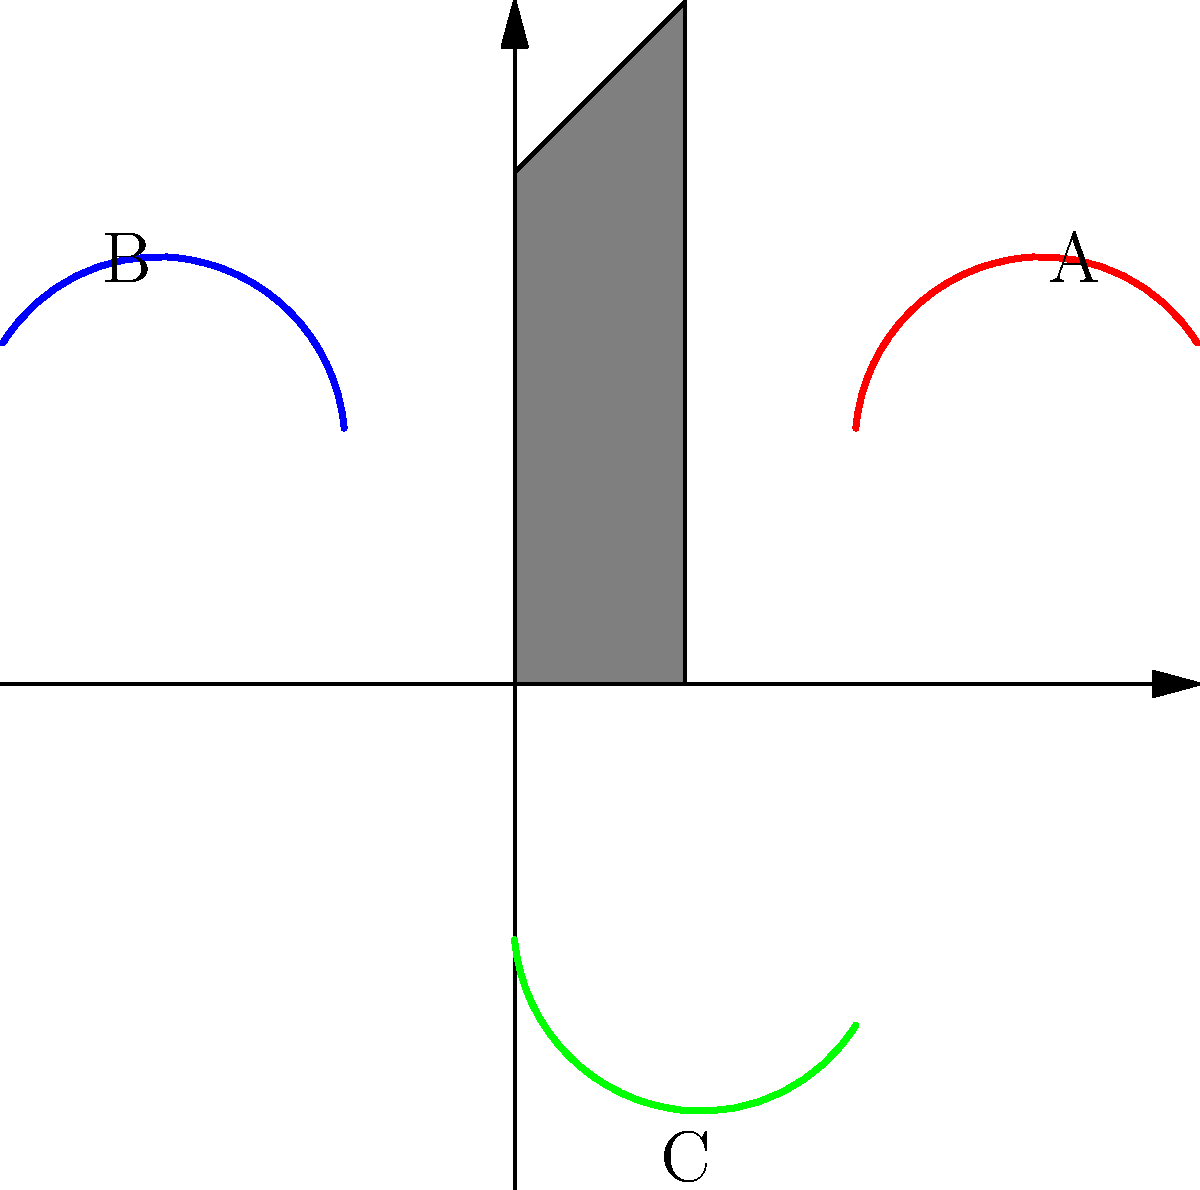As a dedicated Tanya Chua fan, you've noticed her unique microphone handling techniques during performances. In the diagram, three common microphone grips (A, B, and C) are shown. Which grip is most ergonomically suitable for extended singing sessions, considering factors like wrist strain and vocal projection? To determine the most ergonomically suitable microphone grip for extended singing sessions, we need to consider several factors:

1. Wrist strain: A neutral wrist position reduces the risk of repetitive strain injuries.
2. Arm fatigue: A grip that allows the arm to remain in a relaxed position is preferable.
3. Vocal projection: The microphone should be positioned to capture the voice optimally.
4. Flexibility: The grip should allow for easy adjustments during performance.

Analyzing each grip:

A (Red): This grip involves holding the microphone from the side. While it offers good control, it may cause wrist strain over extended periods due to the bent wrist position.

B (Blue): This grip involves holding the microphone from the opposite side. It has similar issues to grip A, potentially causing more strain due to the awkward arm position.

C (Green): This grip involves holding the microphone from the bottom. It allows for a more neutral wrist position and a relaxed arm stance. The microphone can be easily adjusted for optimal vocal capture, and the grip provides stability without excessive tension.

Considering these factors, grip C (Green) is the most ergonomically suitable for extended singing sessions. It minimizes wrist strain, reduces arm fatigue, allows for flexible positioning, and maintains good vocal projection.
Answer: Grip C (Green) 